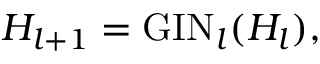Convert formula to latex. <formula><loc_0><loc_0><loc_500><loc_500>H _ { l + 1 } = G I N _ { l } ( H _ { l } ) ,</formula> 